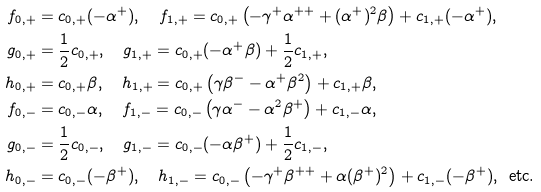<formula> <loc_0><loc_0><loc_500><loc_500>f _ { 0 , + } & = c _ { 0 , + } ( - \alpha ^ { + } ) , \quad f _ { 1 , + } = c _ { 0 , + } \left ( - \gamma ^ { + } \alpha ^ { + + } + ( \alpha ^ { + } ) ^ { 2 } \beta \right ) + c _ { 1 , + } ( - \alpha ^ { + } ) , \\ g _ { 0 , + } & = \frac { 1 } { 2 } c _ { 0 , + } , \quad g _ { 1 , + } = c _ { 0 , + } ( - \alpha ^ { + } \beta ) + \frac { 1 } { 2 } c _ { 1 , + } , \\ h _ { 0 , + } & = c _ { 0 , + } \beta , \quad h _ { 1 , + } = c _ { 0 , + } \left ( \gamma \beta ^ { - } - \alpha ^ { + } \beta ^ { 2 } \right ) + c _ { 1 , + } \beta , \\ f _ { 0 , - } & = c _ { 0 , - } \alpha , \quad f _ { 1 , - } = c _ { 0 , - } \left ( \gamma \alpha ^ { - } - \alpha ^ { 2 } \beta ^ { + } \right ) + c _ { 1 , - } \alpha , \\ g _ { 0 , - } & = \frac { 1 } { 2 } c _ { 0 , - } , \quad g _ { 1 , - } = c _ { 0 , - } ( - \alpha \beta ^ { + } ) + \frac { 1 } { 2 } c _ { 1 , - } , \\ h _ { 0 , - } & = c _ { 0 , - } ( - \beta ^ { + } ) , \quad h _ { 1 , - } = c _ { 0 , - } \left ( - \gamma ^ { + } \beta ^ { + + } + \alpha ( \beta ^ { + } ) ^ { 2 } \right ) + c _ { 1 , - } ( - \beta ^ { + } ) , \, \text { etc.}</formula> 